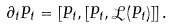<formula> <loc_0><loc_0><loc_500><loc_500>\partial _ { t } P _ { t } = [ P _ { t } , [ P _ { t } , \mathcal { L } ( P _ { t } ) ] ] \, .</formula> 